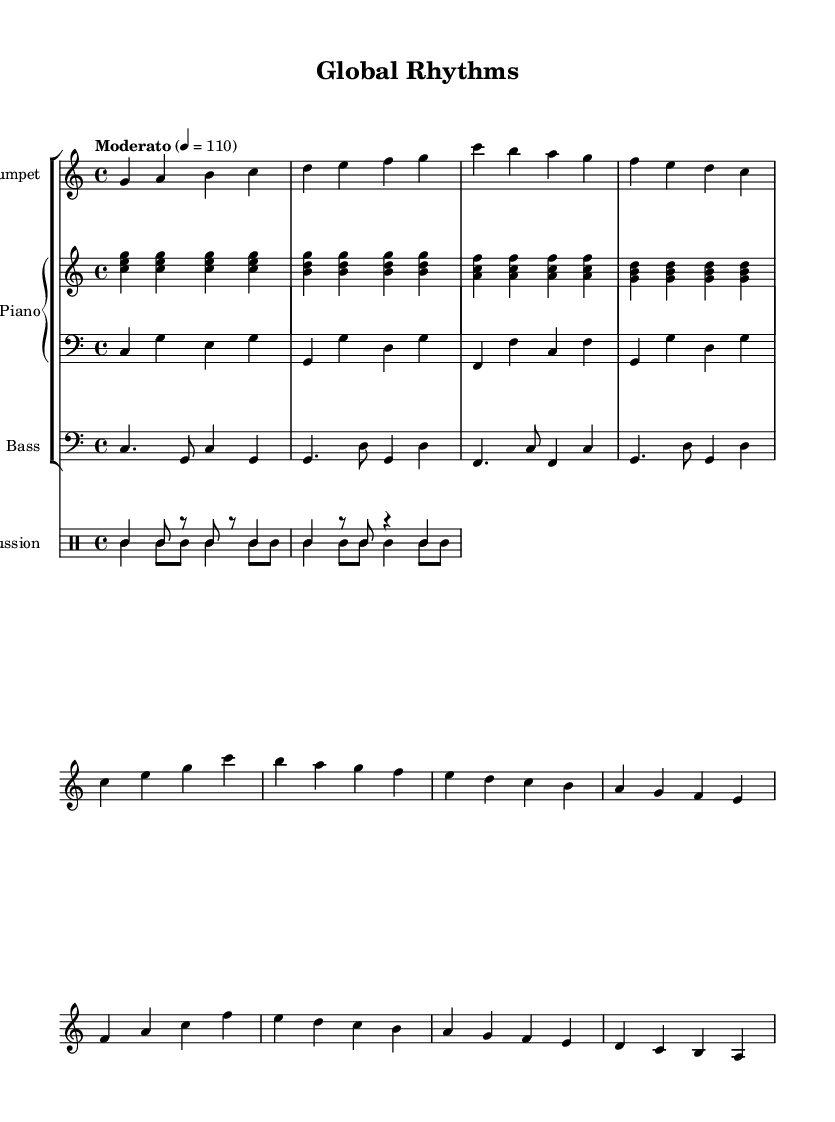What is the key signature of this music? The key signature is C major, which is indicated at the beginning of the staff and has no sharps or flats.
Answer: C major What is the time signature of this music? The time signature is shown as 4/4 at the beginning of the piece, which means there are four beats in each measure and a quarter note receives one beat.
Answer: 4/4 What is the tempo marking for the music? The tempo marking is indicated at the beginning with "Moderato," followed by the metronome marking of 110 beats per minute, which suggests a moderate speed for performance.
Answer: Moderato, 110 What instrument plays the melody in this piece? The melody is primarily played by the trumpet, which is identified at the start of its staff in the sheet music.
Answer: Trumpet How many bars are in the A section of the piece? The A section has a total of eight bars, as there are two phrases of four measures each represented visually in the sheet music.
Answer: 8 bars What is the rhythmic pattern used for the percussion section? The percussion section features a clave pattern and a conga pattern, which are common in Latin jazz, providing a distinctive rhythmic foundation recognizable in the music.
Answer: Clave and conga patterns Which chord is predominantly used in the piano for the A section? The A section features a repeated C major chord in the right hand of the piano, underpinning the harmonic content during that section.
Answer: C major chord 